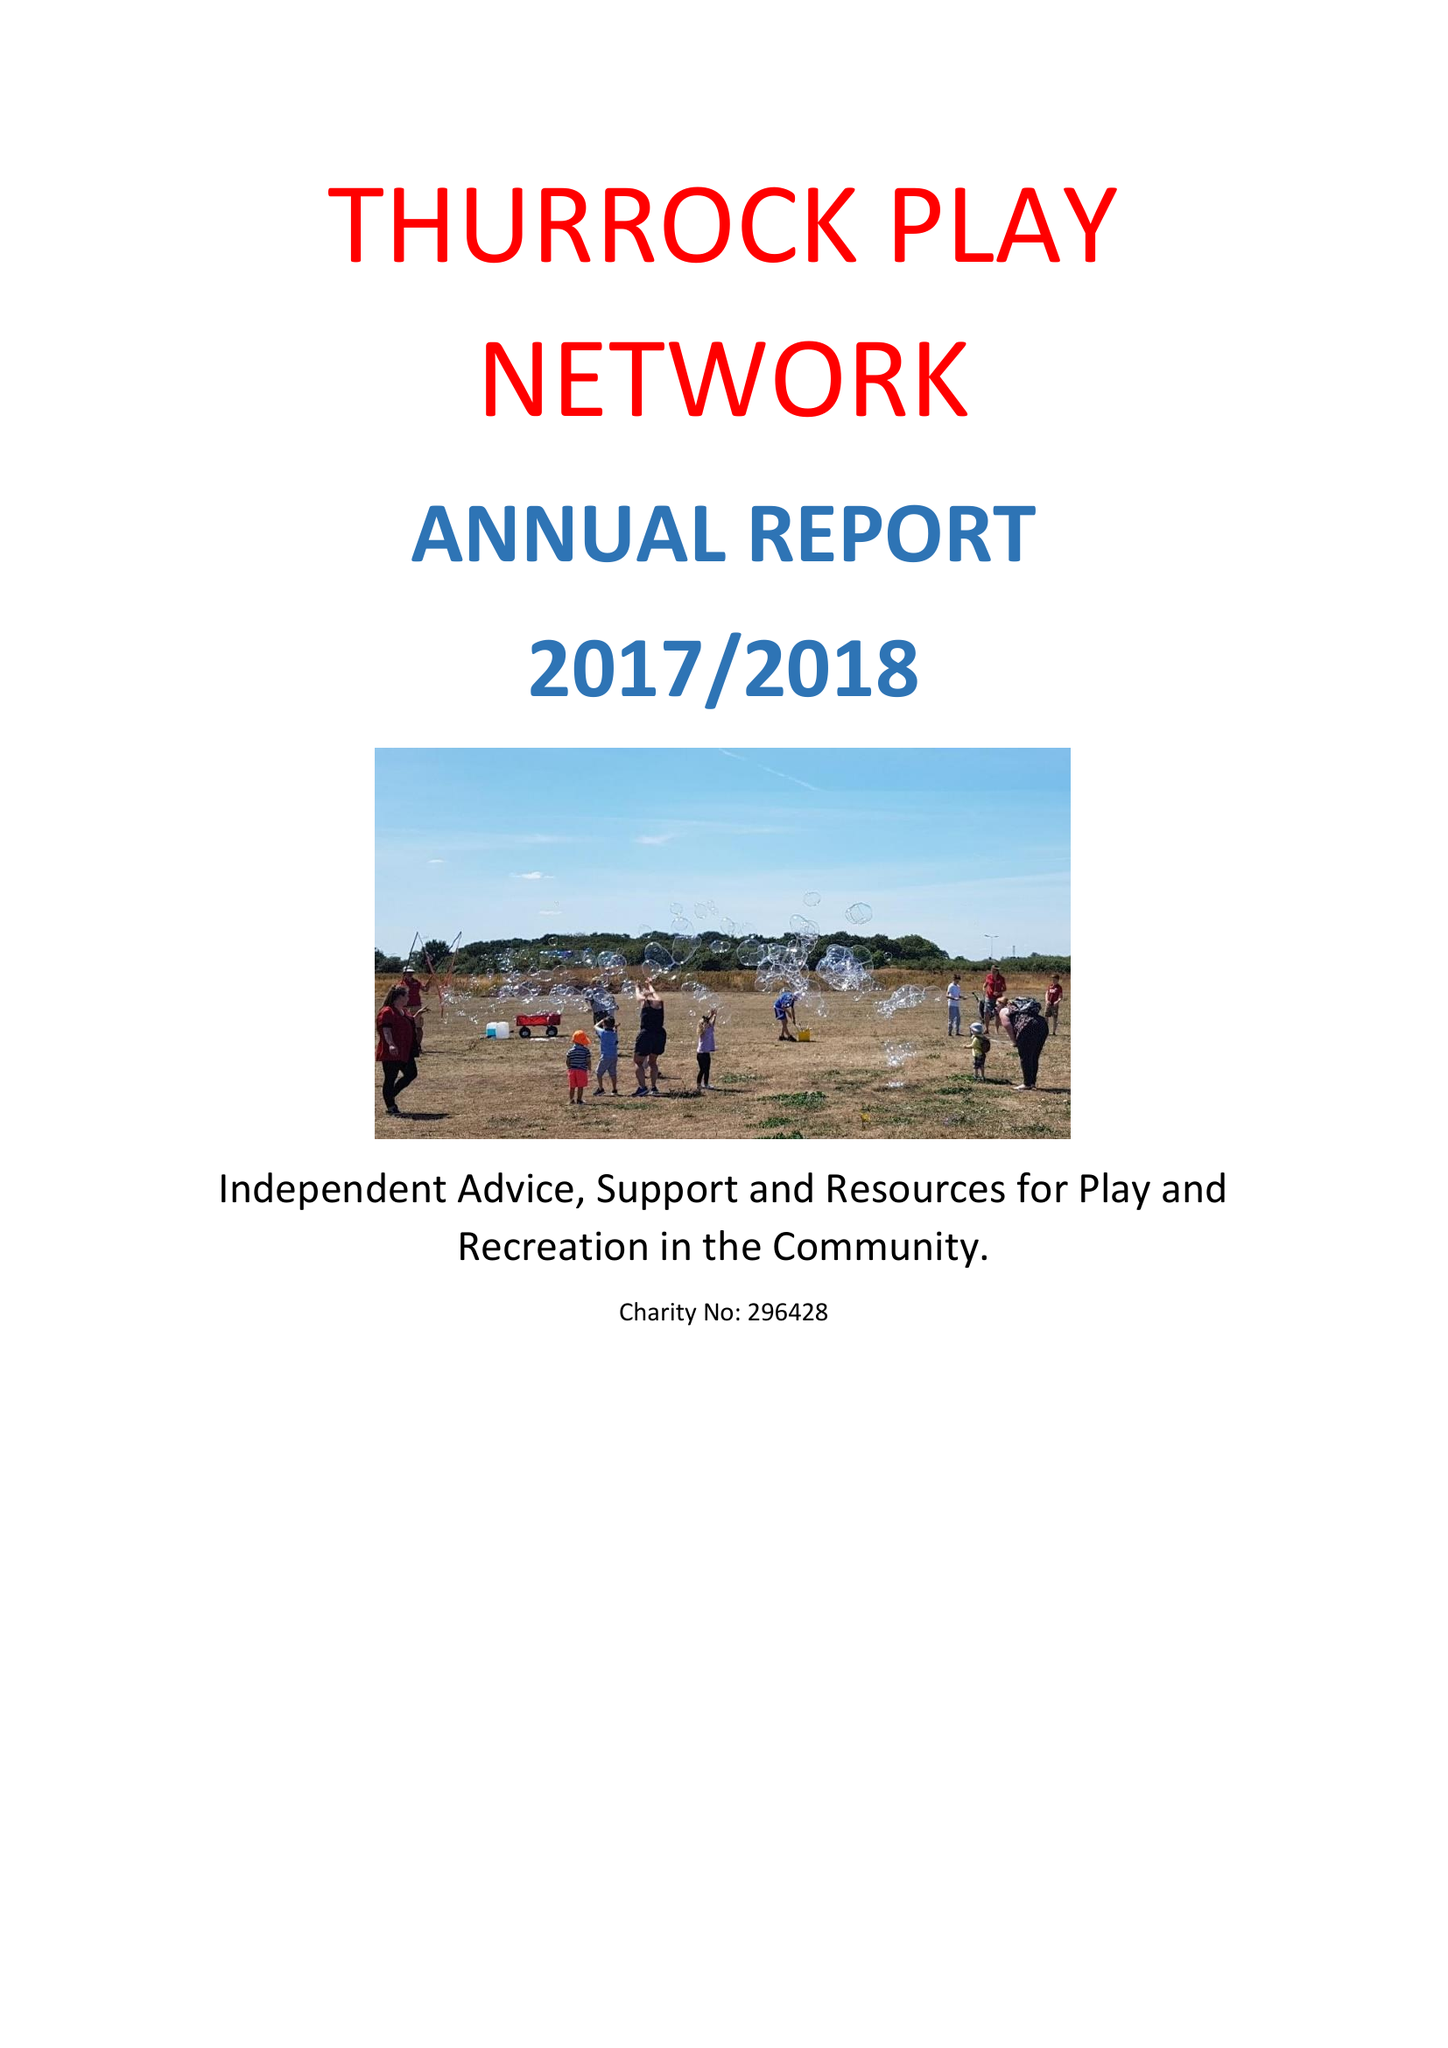What is the value for the income_annually_in_british_pounds?
Answer the question using a single word or phrase. 64048.00 